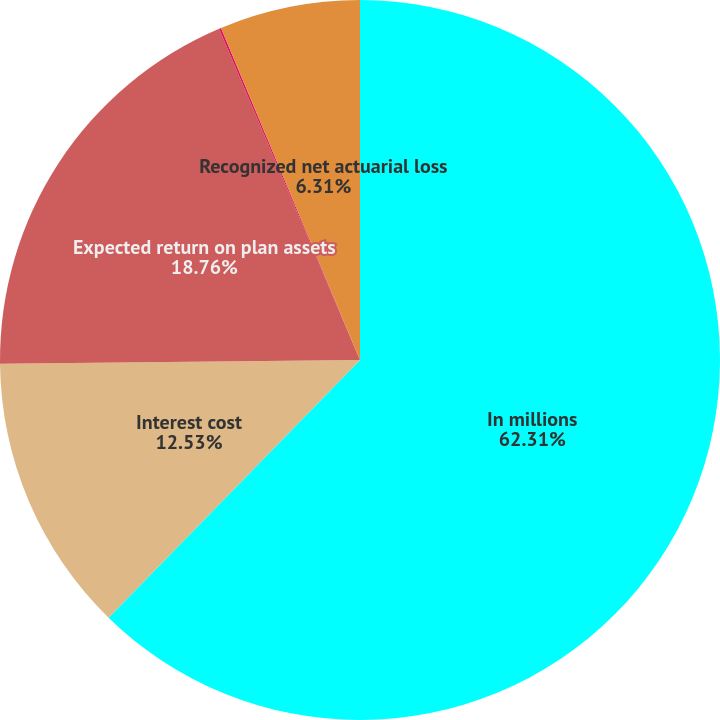<chart> <loc_0><loc_0><loc_500><loc_500><pie_chart><fcel>In millions<fcel>Interest cost<fcel>Expected return on plan assets<fcel>Amortization of prior service<fcel>Recognized net actuarial loss<nl><fcel>62.3%<fcel>12.53%<fcel>18.76%<fcel>0.09%<fcel>6.31%<nl></chart> 